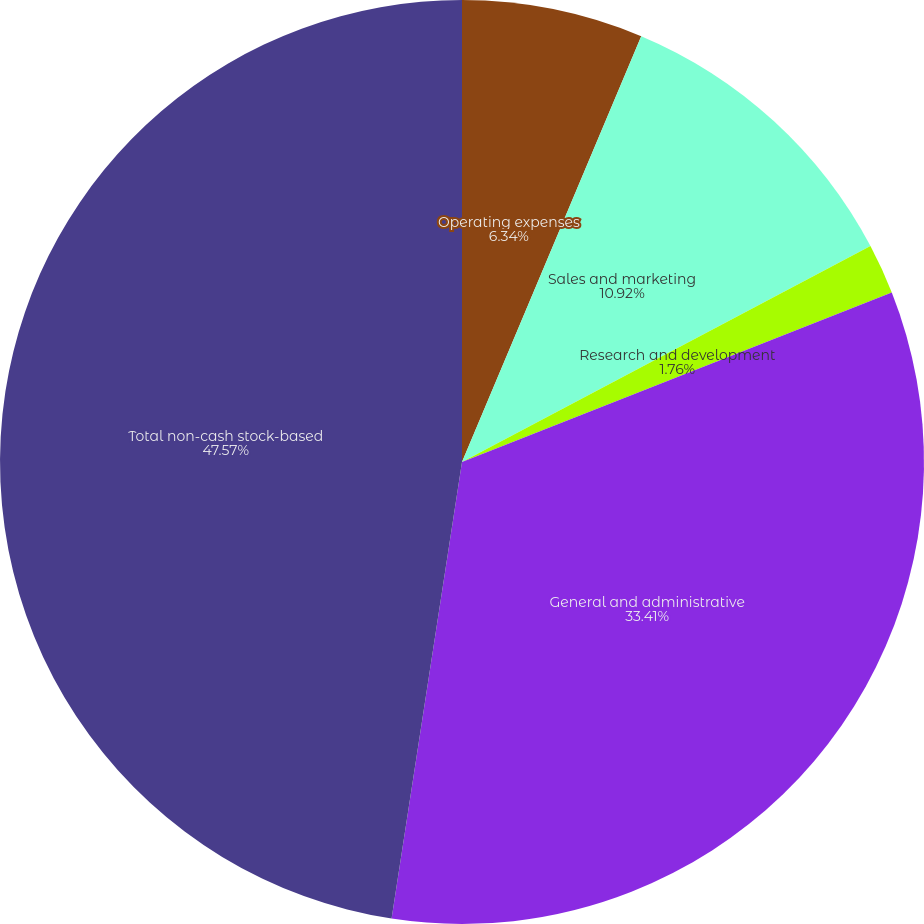<chart> <loc_0><loc_0><loc_500><loc_500><pie_chart><fcel>Operating expenses<fcel>Sales and marketing<fcel>Research and development<fcel>General and administrative<fcel>Total non-cash stock-based<nl><fcel>6.34%<fcel>10.92%<fcel>1.76%<fcel>33.41%<fcel>47.56%<nl></chart> 